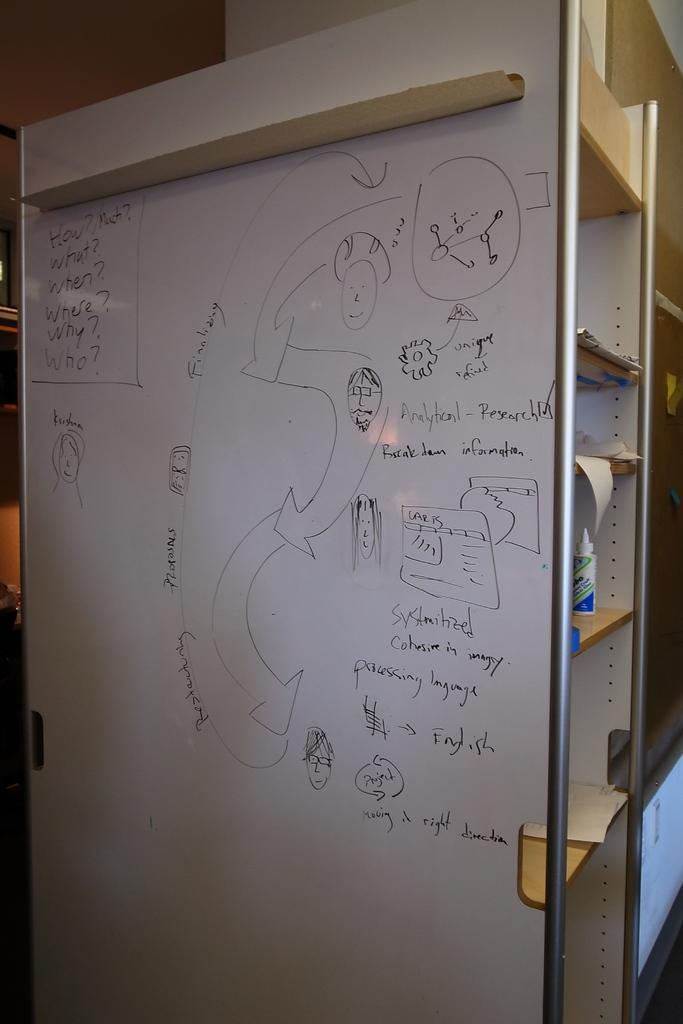<image>
Create a compact narrative representing the image presented. A white board that asks How? What? When? Where? Why? and Who on the side. 